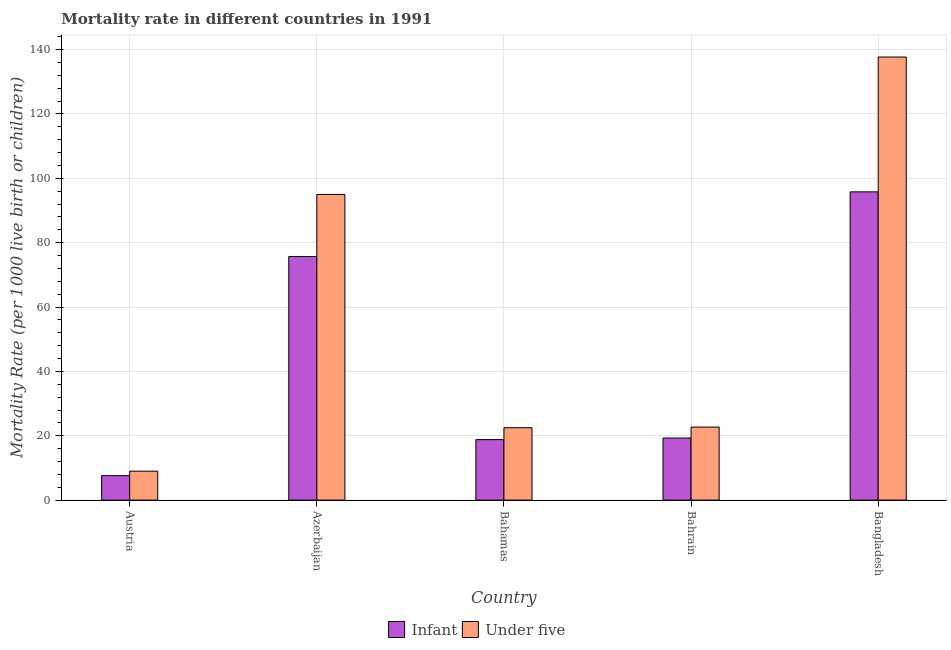How many different coloured bars are there?
Ensure brevity in your answer.  2. How many groups of bars are there?
Provide a short and direct response. 5. Are the number of bars on each tick of the X-axis equal?
Provide a short and direct response. Yes. How many bars are there on the 5th tick from the left?
Offer a terse response. 2. What is the label of the 2nd group of bars from the left?
Offer a very short reply. Azerbaijan. In how many cases, is the number of bars for a given country not equal to the number of legend labels?
Offer a very short reply. 0. What is the under-5 mortality rate in Austria?
Your answer should be compact. 9. Across all countries, what is the maximum infant mortality rate?
Give a very brief answer. 95.8. In which country was the under-5 mortality rate maximum?
Provide a succinct answer. Bangladesh. In which country was the under-5 mortality rate minimum?
Ensure brevity in your answer.  Austria. What is the total infant mortality rate in the graph?
Offer a very short reply. 217.2. What is the difference between the infant mortality rate in Austria and that in Bangladesh?
Provide a succinct answer. -88.2. What is the difference between the under-5 mortality rate in Bangladesh and the infant mortality rate in Austria?
Your answer should be very brief. 130.1. What is the average under-5 mortality rate per country?
Offer a terse response. 57.38. What is the difference between the under-5 mortality rate and infant mortality rate in Bahamas?
Ensure brevity in your answer.  3.7. What is the ratio of the infant mortality rate in Azerbaijan to that in Bangladesh?
Provide a short and direct response. 0.79. Is the under-5 mortality rate in Bahrain less than that in Bangladesh?
Make the answer very short. Yes. What is the difference between the highest and the second highest infant mortality rate?
Offer a terse response. 20.1. What is the difference between the highest and the lowest under-5 mortality rate?
Ensure brevity in your answer.  128.7. Is the sum of the infant mortality rate in Austria and Azerbaijan greater than the maximum under-5 mortality rate across all countries?
Make the answer very short. No. What does the 1st bar from the left in Bangladesh represents?
Provide a short and direct response. Infant. What does the 1st bar from the right in Austria represents?
Provide a succinct answer. Under five. Are all the bars in the graph horizontal?
Offer a terse response. No. Where does the legend appear in the graph?
Provide a succinct answer. Bottom center. How are the legend labels stacked?
Keep it short and to the point. Horizontal. What is the title of the graph?
Offer a very short reply. Mortality rate in different countries in 1991. What is the label or title of the X-axis?
Your answer should be very brief. Country. What is the label or title of the Y-axis?
Your answer should be compact. Mortality Rate (per 1000 live birth or children). What is the Mortality Rate (per 1000 live birth or children) of Infant in Austria?
Ensure brevity in your answer.  7.6. What is the Mortality Rate (per 1000 live birth or children) of Under five in Austria?
Your answer should be very brief. 9. What is the Mortality Rate (per 1000 live birth or children) of Infant in Azerbaijan?
Ensure brevity in your answer.  75.7. What is the Mortality Rate (per 1000 live birth or children) of Under five in Azerbaijan?
Keep it short and to the point. 95. What is the Mortality Rate (per 1000 live birth or children) of Infant in Bahamas?
Give a very brief answer. 18.8. What is the Mortality Rate (per 1000 live birth or children) in Infant in Bahrain?
Your answer should be compact. 19.3. What is the Mortality Rate (per 1000 live birth or children) of Under five in Bahrain?
Offer a very short reply. 22.7. What is the Mortality Rate (per 1000 live birth or children) of Infant in Bangladesh?
Your answer should be very brief. 95.8. What is the Mortality Rate (per 1000 live birth or children) of Under five in Bangladesh?
Provide a short and direct response. 137.7. Across all countries, what is the maximum Mortality Rate (per 1000 live birth or children) in Infant?
Your answer should be compact. 95.8. Across all countries, what is the maximum Mortality Rate (per 1000 live birth or children) of Under five?
Provide a short and direct response. 137.7. Across all countries, what is the minimum Mortality Rate (per 1000 live birth or children) of Under five?
Make the answer very short. 9. What is the total Mortality Rate (per 1000 live birth or children) in Infant in the graph?
Offer a very short reply. 217.2. What is the total Mortality Rate (per 1000 live birth or children) in Under five in the graph?
Keep it short and to the point. 286.9. What is the difference between the Mortality Rate (per 1000 live birth or children) in Infant in Austria and that in Azerbaijan?
Offer a very short reply. -68.1. What is the difference between the Mortality Rate (per 1000 live birth or children) in Under five in Austria and that in Azerbaijan?
Give a very brief answer. -86. What is the difference between the Mortality Rate (per 1000 live birth or children) in Infant in Austria and that in Bahrain?
Offer a terse response. -11.7. What is the difference between the Mortality Rate (per 1000 live birth or children) of Under five in Austria and that in Bahrain?
Offer a very short reply. -13.7. What is the difference between the Mortality Rate (per 1000 live birth or children) of Infant in Austria and that in Bangladesh?
Offer a very short reply. -88.2. What is the difference between the Mortality Rate (per 1000 live birth or children) of Under five in Austria and that in Bangladesh?
Provide a short and direct response. -128.7. What is the difference between the Mortality Rate (per 1000 live birth or children) of Infant in Azerbaijan and that in Bahamas?
Provide a succinct answer. 56.9. What is the difference between the Mortality Rate (per 1000 live birth or children) of Under five in Azerbaijan and that in Bahamas?
Provide a short and direct response. 72.5. What is the difference between the Mortality Rate (per 1000 live birth or children) in Infant in Azerbaijan and that in Bahrain?
Make the answer very short. 56.4. What is the difference between the Mortality Rate (per 1000 live birth or children) in Under five in Azerbaijan and that in Bahrain?
Provide a short and direct response. 72.3. What is the difference between the Mortality Rate (per 1000 live birth or children) in Infant in Azerbaijan and that in Bangladesh?
Make the answer very short. -20.1. What is the difference between the Mortality Rate (per 1000 live birth or children) of Under five in Azerbaijan and that in Bangladesh?
Offer a very short reply. -42.7. What is the difference between the Mortality Rate (per 1000 live birth or children) of Under five in Bahamas and that in Bahrain?
Give a very brief answer. -0.2. What is the difference between the Mortality Rate (per 1000 live birth or children) of Infant in Bahamas and that in Bangladesh?
Offer a terse response. -77. What is the difference between the Mortality Rate (per 1000 live birth or children) in Under five in Bahamas and that in Bangladesh?
Provide a succinct answer. -115.2. What is the difference between the Mortality Rate (per 1000 live birth or children) of Infant in Bahrain and that in Bangladesh?
Your answer should be very brief. -76.5. What is the difference between the Mortality Rate (per 1000 live birth or children) in Under five in Bahrain and that in Bangladesh?
Provide a succinct answer. -115. What is the difference between the Mortality Rate (per 1000 live birth or children) in Infant in Austria and the Mortality Rate (per 1000 live birth or children) in Under five in Azerbaijan?
Offer a terse response. -87.4. What is the difference between the Mortality Rate (per 1000 live birth or children) in Infant in Austria and the Mortality Rate (per 1000 live birth or children) in Under five in Bahamas?
Provide a succinct answer. -14.9. What is the difference between the Mortality Rate (per 1000 live birth or children) in Infant in Austria and the Mortality Rate (per 1000 live birth or children) in Under five in Bahrain?
Your answer should be very brief. -15.1. What is the difference between the Mortality Rate (per 1000 live birth or children) in Infant in Austria and the Mortality Rate (per 1000 live birth or children) in Under five in Bangladesh?
Offer a terse response. -130.1. What is the difference between the Mortality Rate (per 1000 live birth or children) in Infant in Azerbaijan and the Mortality Rate (per 1000 live birth or children) in Under five in Bahamas?
Provide a short and direct response. 53.2. What is the difference between the Mortality Rate (per 1000 live birth or children) in Infant in Azerbaijan and the Mortality Rate (per 1000 live birth or children) in Under five in Bangladesh?
Make the answer very short. -62. What is the difference between the Mortality Rate (per 1000 live birth or children) of Infant in Bahamas and the Mortality Rate (per 1000 live birth or children) of Under five in Bahrain?
Offer a very short reply. -3.9. What is the difference between the Mortality Rate (per 1000 live birth or children) in Infant in Bahamas and the Mortality Rate (per 1000 live birth or children) in Under five in Bangladesh?
Your answer should be compact. -118.9. What is the difference between the Mortality Rate (per 1000 live birth or children) of Infant in Bahrain and the Mortality Rate (per 1000 live birth or children) of Under five in Bangladesh?
Provide a short and direct response. -118.4. What is the average Mortality Rate (per 1000 live birth or children) in Infant per country?
Offer a terse response. 43.44. What is the average Mortality Rate (per 1000 live birth or children) of Under five per country?
Offer a terse response. 57.38. What is the difference between the Mortality Rate (per 1000 live birth or children) of Infant and Mortality Rate (per 1000 live birth or children) of Under five in Azerbaijan?
Provide a succinct answer. -19.3. What is the difference between the Mortality Rate (per 1000 live birth or children) of Infant and Mortality Rate (per 1000 live birth or children) of Under five in Bangladesh?
Make the answer very short. -41.9. What is the ratio of the Mortality Rate (per 1000 live birth or children) of Infant in Austria to that in Azerbaijan?
Your answer should be compact. 0.1. What is the ratio of the Mortality Rate (per 1000 live birth or children) of Under five in Austria to that in Azerbaijan?
Make the answer very short. 0.09. What is the ratio of the Mortality Rate (per 1000 live birth or children) in Infant in Austria to that in Bahamas?
Provide a succinct answer. 0.4. What is the ratio of the Mortality Rate (per 1000 live birth or children) in Under five in Austria to that in Bahamas?
Provide a short and direct response. 0.4. What is the ratio of the Mortality Rate (per 1000 live birth or children) in Infant in Austria to that in Bahrain?
Offer a terse response. 0.39. What is the ratio of the Mortality Rate (per 1000 live birth or children) in Under five in Austria to that in Bahrain?
Your answer should be very brief. 0.4. What is the ratio of the Mortality Rate (per 1000 live birth or children) in Infant in Austria to that in Bangladesh?
Offer a very short reply. 0.08. What is the ratio of the Mortality Rate (per 1000 live birth or children) of Under five in Austria to that in Bangladesh?
Provide a short and direct response. 0.07. What is the ratio of the Mortality Rate (per 1000 live birth or children) in Infant in Azerbaijan to that in Bahamas?
Offer a terse response. 4.03. What is the ratio of the Mortality Rate (per 1000 live birth or children) in Under five in Azerbaijan to that in Bahamas?
Provide a succinct answer. 4.22. What is the ratio of the Mortality Rate (per 1000 live birth or children) in Infant in Azerbaijan to that in Bahrain?
Offer a terse response. 3.92. What is the ratio of the Mortality Rate (per 1000 live birth or children) of Under five in Azerbaijan to that in Bahrain?
Your answer should be compact. 4.18. What is the ratio of the Mortality Rate (per 1000 live birth or children) in Infant in Azerbaijan to that in Bangladesh?
Give a very brief answer. 0.79. What is the ratio of the Mortality Rate (per 1000 live birth or children) of Under five in Azerbaijan to that in Bangladesh?
Give a very brief answer. 0.69. What is the ratio of the Mortality Rate (per 1000 live birth or children) in Infant in Bahamas to that in Bahrain?
Ensure brevity in your answer.  0.97. What is the ratio of the Mortality Rate (per 1000 live birth or children) in Under five in Bahamas to that in Bahrain?
Keep it short and to the point. 0.99. What is the ratio of the Mortality Rate (per 1000 live birth or children) in Infant in Bahamas to that in Bangladesh?
Your answer should be very brief. 0.2. What is the ratio of the Mortality Rate (per 1000 live birth or children) of Under five in Bahamas to that in Bangladesh?
Your answer should be compact. 0.16. What is the ratio of the Mortality Rate (per 1000 live birth or children) of Infant in Bahrain to that in Bangladesh?
Provide a succinct answer. 0.2. What is the ratio of the Mortality Rate (per 1000 live birth or children) of Under five in Bahrain to that in Bangladesh?
Give a very brief answer. 0.16. What is the difference between the highest and the second highest Mortality Rate (per 1000 live birth or children) in Infant?
Provide a succinct answer. 20.1. What is the difference between the highest and the second highest Mortality Rate (per 1000 live birth or children) in Under five?
Make the answer very short. 42.7. What is the difference between the highest and the lowest Mortality Rate (per 1000 live birth or children) of Infant?
Provide a succinct answer. 88.2. What is the difference between the highest and the lowest Mortality Rate (per 1000 live birth or children) in Under five?
Ensure brevity in your answer.  128.7. 